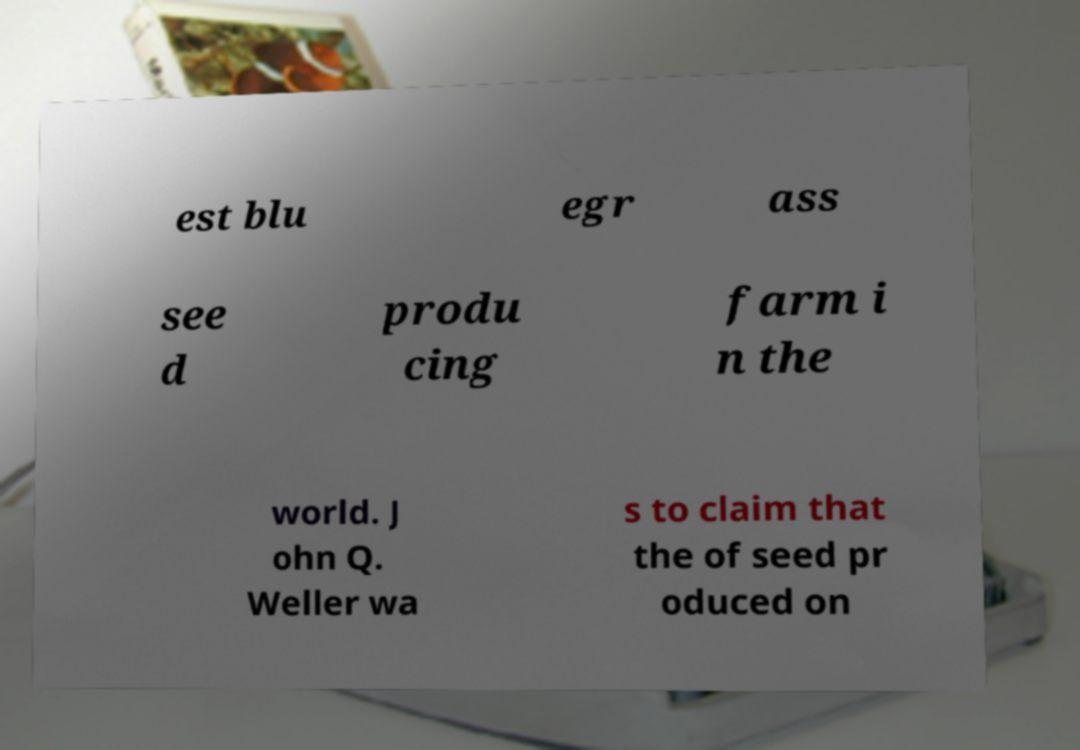Can you read and provide the text displayed in the image?This photo seems to have some interesting text. Can you extract and type it out for me? est blu egr ass see d produ cing farm i n the world. J ohn Q. Weller wa s to claim that the of seed pr oduced on 